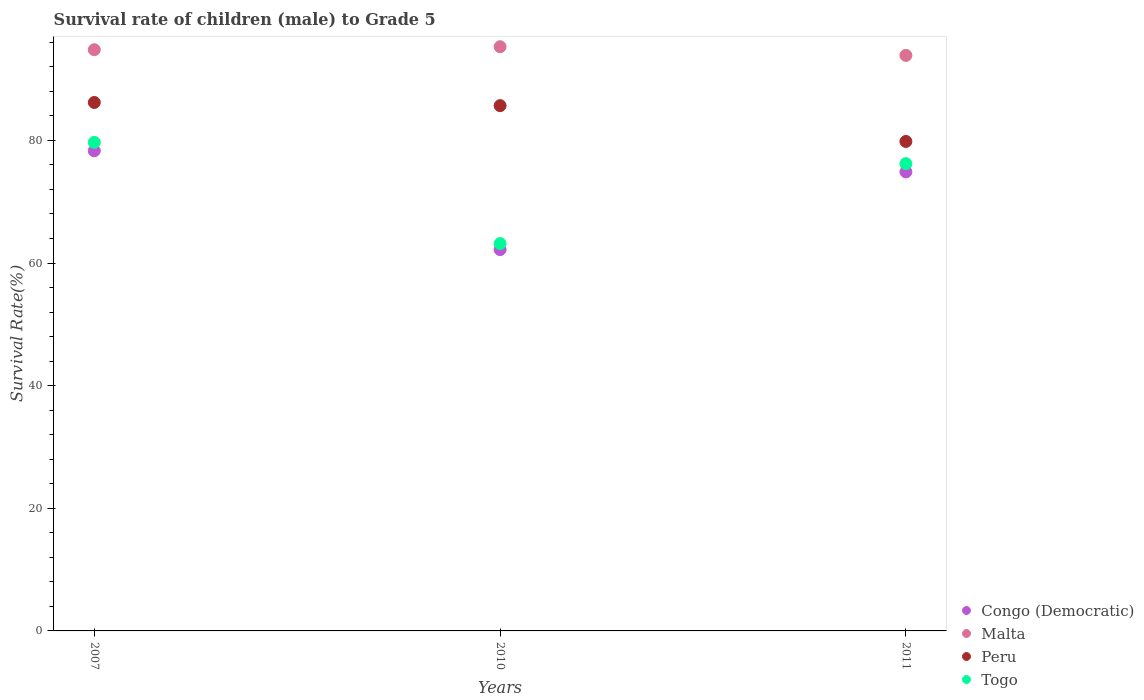How many different coloured dotlines are there?
Offer a terse response. 4. What is the survival rate of male children to grade 5 in Congo (Democratic) in 2010?
Give a very brief answer. 62.2. Across all years, what is the maximum survival rate of male children to grade 5 in Peru?
Your response must be concise. 86.19. Across all years, what is the minimum survival rate of male children to grade 5 in Peru?
Your answer should be very brief. 79.83. In which year was the survival rate of male children to grade 5 in Malta minimum?
Your answer should be compact. 2011. What is the total survival rate of male children to grade 5 in Togo in the graph?
Give a very brief answer. 219.06. What is the difference between the survival rate of male children to grade 5 in Togo in 2010 and that in 2011?
Provide a short and direct response. -13.04. What is the difference between the survival rate of male children to grade 5 in Malta in 2010 and the survival rate of male children to grade 5 in Peru in 2007?
Your answer should be very brief. 9.09. What is the average survival rate of male children to grade 5 in Malta per year?
Your answer should be very brief. 94.65. In the year 2011, what is the difference between the survival rate of male children to grade 5 in Peru and survival rate of male children to grade 5 in Togo?
Make the answer very short. 3.62. What is the ratio of the survival rate of male children to grade 5 in Congo (Democratic) in 2007 to that in 2010?
Ensure brevity in your answer.  1.26. Is the survival rate of male children to grade 5 in Togo in 2007 less than that in 2010?
Provide a short and direct response. No. Is the difference between the survival rate of male children to grade 5 in Peru in 2010 and 2011 greater than the difference between the survival rate of male children to grade 5 in Togo in 2010 and 2011?
Provide a short and direct response. Yes. What is the difference between the highest and the second highest survival rate of male children to grade 5 in Congo (Democratic)?
Your answer should be compact. 3.44. What is the difference between the highest and the lowest survival rate of male children to grade 5 in Peru?
Your answer should be very brief. 6.36. In how many years, is the survival rate of male children to grade 5 in Togo greater than the average survival rate of male children to grade 5 in Togo taken over all years?
Keep it short and to the point. 2. Is the sum of the survival rate of male children to grade 5 in Peru in 2007 and 2011 greater than the maximum survival rate of male children to grade 5 in Togo across all years?
Ensure brevity in your answer.  Yes. Is it the case that in every year, the sum of the survival rate of male children to grade 5 in Congo (Democratic) and survival rate of male children to grade 5 in Peru  is greater than the sum of survival rate of male children to grade 5 in Togo and survival rate of male children to grade 5 in Malta?
Your response must be concise. Yes. Does the survival rate of male children to grade 5 in Peru monotonically increase over the years?
Provide a succinct answer. No. Is the survival rate of male children to grade 5 in Congo (Democratic) strictly less than the survival rate of male children to grade 5 in Malta over the years?
Offer a terse response. Yes. How many dotlines are there?
Offer a very short reply. 4. How many years are there in the graph?
Your response must be concise. 3. What is the difference between two consecutive major ticks on the Y-axis?
Provide a succinct answer. 20. Does the graph contain any zero values?
Your answer should be compact. No. How are the legend labels stacked?
Keep it short and to the point. Vertical. What is the title of the graph?
Keep it short and to the point. Survival rate of children (male) to Grade 5. What is the label or title of the X-axis?
Provide a succinct answer. Years. What is the label or title of the Y-axis?
Make the answer very short. Survival Rate(%). What is the Survival Rate(%) of Congo (Democratic) in 2007?
Provide a short and direct response. 78.31. What is the Survival Rate(%) in Malta in 2007?
Give a very brief answer. 94.8. What is the Survival Rate(%) of Peru in 2007?
Make the answer very short. 86.19. What is the Survival Rate(%) in Togo in 2007?
Your response must be concise. 79.68. What is the Survival Rate(%) of Congo (Democratic) in 2010?
Your answer should be compact. 62.2. What is the Survival Rate(%) of Malta in 2010?
Give a very brief answer. 95.28. What is the Survival Rate(%) of Peru in 2010?
Ensure brevity in your answer.  85.67. What is the Survival Rate(%) of Togo in 2010?
Your answer should be compact. 63.17. What is the Survival Rate(%) of Congo (Democratic) in 2011?
Offer a very short reply. 74.87. What is the Survival Rate(%) in Malta in 2011?
Your response must be concise. 93.87. What is the Survival Rate(%) of Peru in 2011?
Ensure brevity in your answer.  79.83. What is the Survival Rate(%) in Togo in 2011?
Ensure brevity in your answer.  76.21. Across all years, what is the maximum Survival Rate(%) in Congo (Democratic)?
Offer a very short reply. 78.31. Across all years, what is the maximum Survival Rate(%) of Malta?
Offer a very short reply. 95.28. Across all years, what is the maximum Survival Rate(%) of Peru?
Your answer should be very brief. 86.19. Across all years, what is the maximum Survival Rate(%) in Togo?
Offer a terse response. 79.68. Across all years, what is the minimum Survival Rate(%) in Congo (Democratic)?
Your response must be concise. 62.2. Across all years, what is the minimum Survival Rate(%) in Malta?
Provide a succinct answer. 93.87. Across all years, what is the minimum Survival Rate(%) of Peru?
Your answer should be compact. 79.83. Across all years, what is the minimum Survival Rate(%) of Togo?
Offer a very short reply. 63.17. What is the total Survival Rate(%) of Congo (Democratic) in the graph?
Keep it short and to the point. 215.37. What is the total Survival Rate(%) in Malta in the graph?
Give a very brief answer. 283.95. What is the total Survival Rate(%) of Peru in the graph?
Offer a very short reply. 251.69. What is the total Survival Rate(%) of Togo in the graph?
Offer a terse response. 219.06. What is the difference between the Survival Rate(%) in Congo (Democratic) in 2007 and that in 2010?
Your answer should be very brief. 16.11. What is the difference between the Survival Rate(%) of Malta in 2007 and that in 2010?
Ensure brevity in your answer.  -0.49. What is the difference between the Survival Rate(%) of Peru in 2007 and that in 2010?
Your response must be concise. 0.52. What is the difference between the Survival Rate(%) in Togo in 2007 and that in 2010?
Give a very brief answer. 16.51. What is the difference between the Survival Rate(%) of Congo (Democratic) in 2007 and that in 2011?
Give a very brief answer. 3.44. What is the difference between the Survival Rate(%) in Malta in 2007 and that in 2011?
Give a very brief answer. 0.93. What is the difference between the Survival Rate(%) in Peru in 2007 and that in 2011?
Keep it short and to the point. 6.36. What is the difference between the Survival Rate(%) in Togo in 2007 and that in 2011?
Provide a succinct answer. 3.47. What is the difference between the Survival Rate(%) in Congo (Democratic) in 2010 and that in 2011?
Keep it short and to the point. -12.67. What is the difference between the Survival Rate(%) in Malta in 2010 and that in 2011?
Offer a terse response. 1.42. What is the difference between the Survival Rate(%) of Peru in 2010 and that in 2011?
Your response must be concise. 5.84. What is the difference between the Survival Rate(%) in Togo in 2010 and that in 2011?
Offer a terse response. -13.04. What is the difference between the Survival Rate(%) in Congo (Democratic) in 2007 and the Survival Rate(%) in Malta in 2010?
Make the answer very short. -16.98. What is the difference between the Survival Rate(%) in Congo (Democratic) in 2007 and the Survival Rate(%) in Peru in 2010?
Provide a short and direct response. -7.37. What is the difference between the Survival Rate(%) in Congo (Democratic) in 2007 and the Survival Rate(%) in Togo in 2010?
Give a very brief answer. 15.13. What is the difference between the Survival Rate(%) of Malta in 2007 and the Survival Rate(%) of Peru in 2010?
Provide a short and direct response. 9.12. What is the difference between the Survival Rate(%) of Malta in 2007 and the Survival Rate(%) of Togo in 2010?
Your response must be concise. 31.62. What is the difference between the Survival Rate(%) in Peru in 2007 and the Survival Rate(%) in Togo in 2010?
Ensure brevity in your answer.  23.02. What is the difference between the Survival Rate(%) of Congo (Democratic) in 2007 and the Survival Rate(%) of Malta in 2011?
Give a very brief answer. -15.56. What is the difference between the Survival Rate(%) of Congo (Democratic) in 2007 and the Survival Rate(%) of Peru in 2011?
Offer a terse response. -1.52. What is the difference between the Survival Rate(%) in Congo (Democratic) in 2007 and the Survival Rate(%) in Togo in 2011?
Make the answer very short. 2.1. What is the difference between the Survival Rate(%) in Malta in 2007 and the Survival Rate(%) in Peru in 2011?
Your response must be concise. 14.97. What is the difference between the Survival Rate(%) in Malta in 2007 and the Survival Rate(%) in Togo in 2011?
Make the answer very short. 18.59. What is the difference between the Survival Rate(%) in Peru in 2007 and the Survival Rate(%) in Togo in 2011?
Your answer should be compact. 9.98. What is the difference between the Survival Rate(%) of Congo (Democratic) in 2010 and the Survival Rate(%) of Malta in 2011?
Ensure brevity in your answer.  -31.67. What is the difference between the Survival Rate(%) in Congo (Democratic) in 2010 and the Survival Rate(%) in Peru in 2011?
Provide a succinct answer. -17.63. What is the difference between the Survival Rate(%) in Congo (Democratic) in 2010 and the Survival Rate(%) in Togo in 2011?
Your answer should be compact. -14.01. What is the difference between the Survival Rate(%) in Malta in 2010 and the Survival Rate(%) in Peru in 2011?
Offer a very short reply. 15.45. What is the difference between the Survival Rate(%) of Malta in 2010 and the Survival Rate(%) of Togo in 2011?
Your answer should be very brief. 19.07. What is the difference between the Survival Rate(%) of Peru in 2010 and the Survival Rate(%) of Togo in 2011?
Provide a succinct answer. 9.46. What is the average Survival Rate(%) of Congo (Democratic) per year?
Ensure brevity in your answer.  71.79. What is the average Survival Rate(%) of Malta per year?
Make the answer very short. 94.65. What is the average Survival Rate(%) in Peru per year?
Offer a very short reply. 83.9. What is the average Survival Rate(%) in Togo per year?
Make the answer very short. 73.02. In the year 2007, what is the difference between the Survival Rate(%) of Congo (Democratic) and Survival Rate(%) of Malta?
Give a very brief answer. -16.49. In the year 2007, what is the difference between the Survival Rate(%) in Congo (Democratic) and Survival Rate(%) in Peru?
Your response must be concise. -7.88. In the year 2007, what is the difference between the Survival Rate(%) of Congo (Democratic) and Survival Rate(%) of Togo?
Make the answer very short. -1.37. In the year 2007, what is the difference between the Survival Rate(%) in Malta and Survival Rate(%) in Peru?
Make the answer very short. 8.61. In the year 2007, what is the difference between the Survival Rate(%) of Malta and Survival Rate(%) of Togo?
Ensure brevity in your answer.  15.12. In the year 2007, what is the difference between the Survival Rate(%) in Peru and Survival Rate(%) in Togo?
Your answer should be very brief. 6.51. In the year 2010, what is the difference between the Survival Rate(%) of Congo (Democratic) and Survival Rate(%) of Malta?
Your answer should be compact. -33.09. In the year 2010, what is the difference between the Survival Rate(%) of Congo (Democratic) and Survival Rate(%) of Peru?
Make the answer very short. -23.47. In the year 2010, what is the difference between the Survival Rate(%) in Congo (Democratic) and Survival Rate(%) in Togo?
Ensure brevity in your answer.  -0.97. In the year 2010, what is the difference between the Survival Rate(%) of Malta and Survival Rate(%) of Peru?
Ensure brevity in your answer.  9.61. In the year 2010, what is the difference between the Survival Rate(%) of Malta and Survival Rate(%) of Togo?
Make the answer very short. 32.11. In the year 2011, what is the difference between the Survival Rate(%) of Congo (Democratic) and Survival Rate(%) of Malta?
Offer a terse response. -19. In the year 2011, what is the difference between the Survival Rate(%) of Congo (Democratic) and Survival Rate(%) of Peru?
Provide a short and direct response. -4.96. In the year 2011, what is the difference between the Survival Rate(%) in Congo (Democratic) and Survival Rate(%) in Togo?
Ensure brevity in your answer.  -1.34. In the year 2011, what is the difference between the Survival Rate(%) in Malta and Survival Rate(%) in Peru?
Your answer should be very brief. 14.04. In the year 2011, what is the difference between the Survival Rate(%) of Malta and Survival Rate(%) of Togo?
Provide a short and direct response. 17.66. In the year 2011, what is the difference between the Survival Rate(%) of Peru and Survival Rate(%) of Togo?
Your answer should be very brief. 3.62. What is the ratio of the Survival Rate(%) in Congo (Democratic) in 2007 to that in 2010?
Make the answer very short. 1.26. What is the ratio of the Survival Rate(%) in Malta in 2007 to that in 2010?
Your answer should be very brief. 0.99. What is the ratio of the Survival Rate(%) in Togo in 2007 to that in 2010?
Keep it short and to the point. 1.26. What is the ratio of the Survival Rate(%) of Congo (Democratic) in 2007 to that in 2011?
Your answer should be very brief. 1.05. What is the ratio of the Survival Rate(%) in Malta in 2007 to that in 2011?
Make the answer very short. 1.01. What is the ratio of the Survival Rate(%) in Peru in 2007 to that in 2011?
Make the answer very short. 1.08. What is the ratio of the Survival Rate(%) in Togo in 2007 to that in 2011?
Offer a terse response. 1.05. What is the ratio of the Survival Rate(%) in Congo (Democratic) in 2010 to that in 2011?
Ensure brevity in your answer.  0.83. What is the ratio of the Survival Rate(%) in Malta in 2010 to that in 2011?
Your response must be concise. 1.02. What is the ratio of the Survival Rate(%) of Peru in 2010 to that in 2011?
Make the answer very short. 1.07. What is the ratio of the Survival Rate(%) in Togo in 2010 to that in 2011?
Your answer should be compact. 0.83. What is the difference between the highest and the second highest Survival Rate(%) of Congo (Democratic)?
Provide a short and direct response. 3.44. What is the difference between the highest and the second highest Survival Rate(%) of Malta?
Give a very brief answer. 0.49. What is the difference between the highest and the second highest Survival Rate(%) of Peru?
Provide a succinct answer. 0.52. What is the difference between the highest and the second highest Survival Rate(%) of Togo?
Make the answer very short. 3.47. What is the difference between the highest and the lowest Survival Rate(%) of Congo (Democratic)?
Offer a terse response. 16.11. What is the difference between the highest and the lowest Survival Rate(%) of Malta?
Offer a terse response. 1.42. What is the difference between the highest and the lowest Survival Rate(%) of Peru?
Your answer should be compact. 6.36. What is the difference between the highest and the lowest Survival Rate(%) of Togo?
Provide a short and direct response. 16.51. 